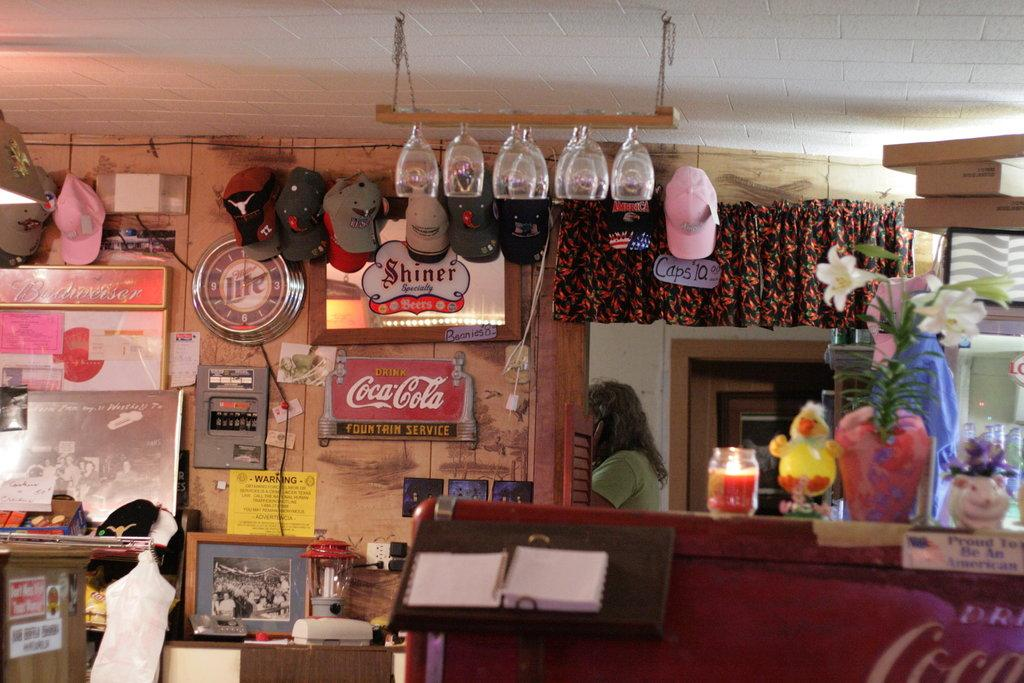<image>
Share a concise interpretation of the image provided. A miller lite clock is on the wall of a diner. 